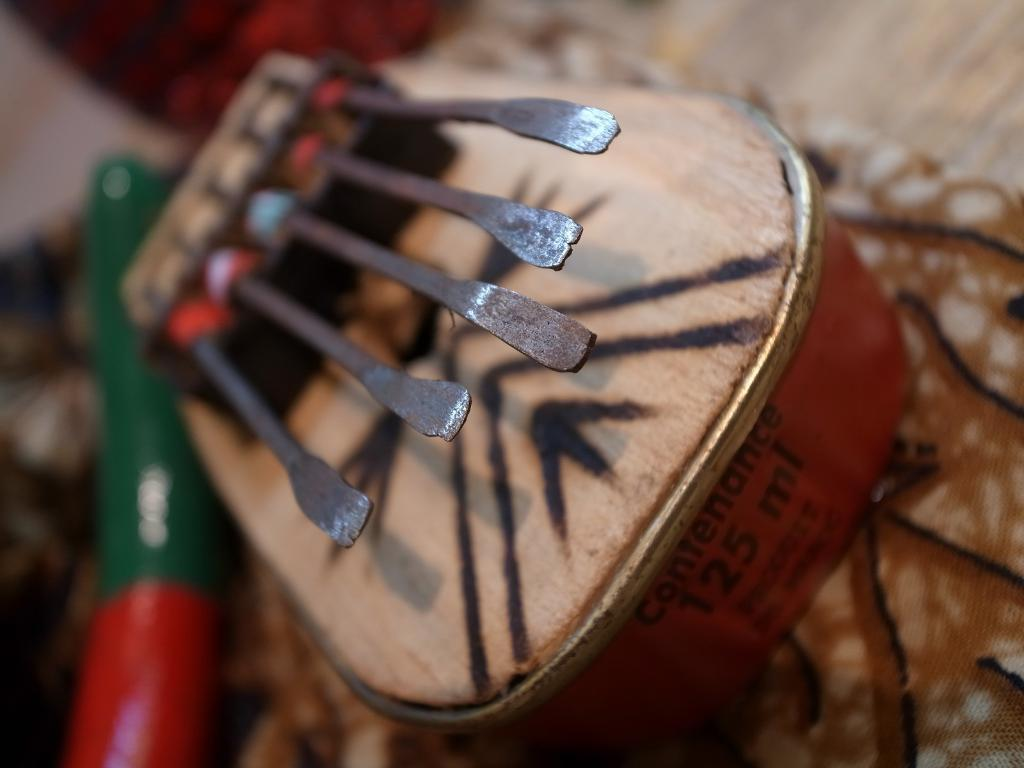What object is the person holding in the image? The person is holding a cup of coffee in the image. What is the person doing with the cup of coffee? The person is likely drinking or about to drink the coffee. What is present in the foreground of the image? There is a table in the foreground of the image. What can be seen in the background of the image? There is a sidewalk in the background of the image. What type of necklace is the person wearing in the image? There is no necklace visible in the image; the person is holding a cup of coffee. 